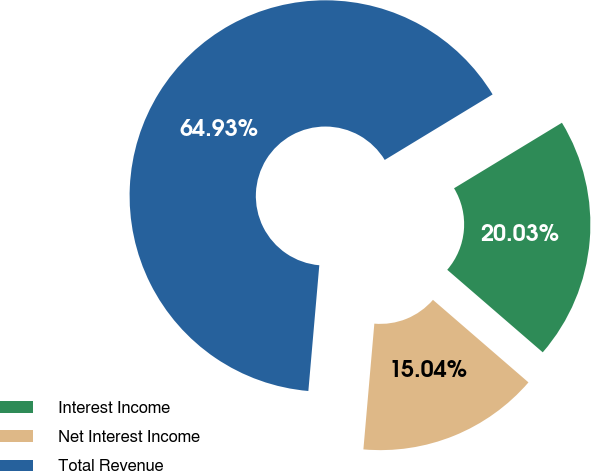<chart> <loc_0><loc_0><loc_500><loc_500><pie_chart><fcel>Interest Income<fcel>Net Interest Income<fcel>Total Revenue<nl><fcel>20.03%<fcel>15.04%<fcel>64.93%<nl></chart> 